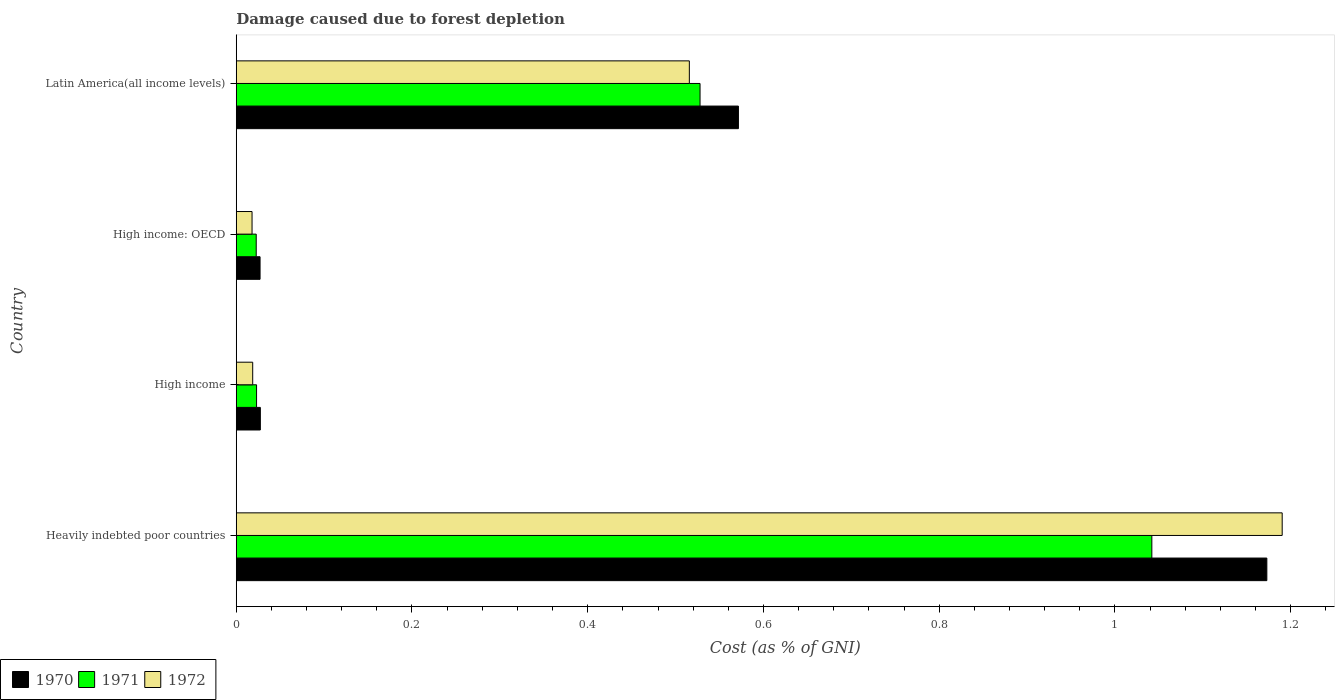How many different coloured bars are there?
Provide a succinct answer. 3. How many groups of bars are there?
Make the answer very short. 4. What is the label of the 1st group of bars from the top?
Provide a succinct answer. Latin America(all income levels). What is the cost of damage caused due to forest depletion in 1971 in High income?
Make the answer very short. 0.02. Across all countries, what is the maximum cost of damage caused due to forest depletion in 1970?
Give a very brief answer. 1.17. Across all countries, what is the minimum cost of damage caused due to forest depletion in 1971?
Offer a terse response. 0.02. In which country was the cost of damage caused due to forest depletion in 1972 maximum?
Give a very brief answer. Heavily indebted poor countries. In which country was the cost of damage caused due to forest depletion in 1970 minimum?
Offer a terse response. High income: OECD. What is the total cost of damage caused due to forest depletion in 1970 in the graph?
Offer a very short reply. 1.8. What is the difference between the cost of damage caused due to forest depletion in 1972 in Heavily indebted poor countries and that in High income?
Ensure brevity in your answer.  1.17. What is the difference between the cost of damage caused due to forest depletion in 1972 in Heavily indebted poor countries and the cost of damage caused due to forest depletion in 1971 in High income: OECD?
Your response must be concise. 1.17. What is the average cost of damage caused due to forest depletion in 1972 per country?
Your response must be concise. 0.44. What is the difference between the cost of damage caused due to forest depletion in 1970 and cost of damage caused due to forest depletion in 1971 in Latin America(all income levels)?
Your answer should be very brief. 0.04. What is the ratio of the cost of damage caused due to forest depletion in 1970 in Heavily indebted poor countries to that in Latin America(all income levels)?
Make the answer very short. 2.05. What is the difference between the highest and the second highest cost of damage caused due to forest depletion in 1972?
Your answer should be compact. 0.67. What is the difference between the highest and the lowest cost of damage caused due to forest depletion in 1971?
Give a very brief answer. 1.02. In how many countries, is the cost of damage caused due to forest depletion in 1970 greater than the average cost of damage caused due to forest depletion in 1970 taken over all countries?
Offer a very short reply. 2. Is it the case that in every country, the sum of the cost of damage caused due to forest depletion in 1971 and cost of damage caused due to forest depletion in 1970 is greater than the cost of damage caused due to forest depletion in 1972?
Your answer should be very brief. Yes. How many bars are there?
Provide a short and direct response. 12. Are all the bars in the graph horizontal?
Provide a short and direct response. Yes. How many countries are there in the graph?
Your answer should be very brief. 4. Does the graph contain any zero values?
Keep it short and to the point. No. Does the graph contain grids?
Your answer should be very brief. No. How many legend labels are there?
Give a very brief answer. 3. How are the legend labels stacked?
Keep it short and to the point. Horizontal. What is the title of the graph?
Keep it short and to the point. Damage caused due to forest depletion. What is the label or title of the X-axis?
Make the answer very short. Cost (as % of GNI). What is the Cost (as % of GNI) in 1970 in Heavily indebted poor countries?
Provide a succinct answer. 1.17. What is the Cost (as % of GNI) of 1971 in Heavily indebted poor countries?
Your answer should be very brief. 1.04. What is the Cost (as % of GNI) of 1972 in Heavily indebted poor countries?
Make the answer very short. 1.19. What is the Cost (as % of GNI) of 1970 in High income?
Offer a terse response. 0.03. What is the Cost (as % of GNI) of 1971 in High income?
Your response must be concise. 0.02. What is the Cost (as % of GNI) of 1972 in High income?
Provide a succinct answer. 0.02. What is the Cost (as % of GNI) of 1970 in High income: OECD?
Keep it short and to the point. 0.03. What is the Cost (as % of GNI) in 1971 in High income: OECD?
Provide a short and direct response. 0.02. What is the Cost (as % of GNI) of 1972 in High income: OECD?
Your response must be concise. 0.02. What is the Cost (as % of GNI) of 1970 in Latin America(all income levels)?
Ensure brevity in your answer.  0.57. What is the Cost (as % of GNI) in 1971 in Latin America(all income levels)?
Your response must be concise. 0.53. What is the Cost (as % of GNI) of 1972 in Latin America(all income levels)?
Your answer should be compact. 0.52. Across all countries, what is the maximum Cost (as % of GNI) of 1970?
Ensure brevity in your answer.  1.17. Across all countries, what is the maximum Cost (as % of GNI) in 1971?
Ensure brevity in your answer.  1.04. Across all countries, what is the maximum Cost (as % of GNI) of 1972?
Your answer should be compact. 1.19. Across all countries, what is the minimum Cost (as % of GNI) in 1970?
Your answer should be very brief. 0.03. Across all countries, what is the minimum Cost (as % of GNI) of 1971?
Make the answer very short. 0.02. Across all countries, what is the minimum Cost (as % of GNI) of 1972?
Ensure brevity in your answer.  0.02. What is the total Cost (as % of GNI) of 1970 in the graph?
Your answer should be compact. 1.8. What is the total Cost (as % of GNI) in 1971 in the graph?
Provide a short and direct response. 1.62. What is the total Cost (as % of GNI) of 1972 in the graph?
Your response must be concise. 1.74. What is the difference between the Cost (as % of GNI) of 1970 in Heavily indebted poor countries and that in High income?
Give a very brief answer. 1.15. What is the difference between the Cost (as % of GNI) of 1971 in Heavily indebted poor countries and that in High income?
Provide a succinct answer. 1.02. What is the difference between the Cost (as % of GNI) in 1972 in Heavily indebted poor countries and that in High income?
Your response must be concise. 1.17. What is the difference between the Cost (as % of GNI) of 1970 in Heavily indebted poor countries and that in High income: OECD?
Your answer should be very brief. 1.15. What is the difference between the Cost (as % of GNI) in 1971 in Heavily indebted poor countries and that in High income: OECD?
Offer a terse response. 1.02. What is the difference between the Cost (as % of GNI) of 1972 in Heavily indebted poor countries and that in High income: OECD?
Make the answer very short. 1.17. What is the difference between the Cost (as % of GNI) of 1970 in Heavily indebted poor countries and that in Latin America(all income levels)?
Your answer should be very brief. 0.6. What is the difference between the Cost (as % of GNI) of 1971 in Heavily indebted poor countries and that in Latin America(all income levels)?
Keep it short and to the point. 0.51. What is the difference between the Cost (as % of GNI) of 1972 in Heavily indebted poor countries and that in Latin America(all income levels)?
Make the answer very short. 0.67. What is the difference between the Cost (as % of GNI) in 1970 in High income and that in High income: OECD?
Offer a terse response. 0. What is the difference between the Cost (as % of GNI) in 1972 in High income and that in High income: OECD?
Offer a very short reply. 0. What is the difference between the Cost (as % of GNI) in 1970 in High income and that in Latin America(all income levels)?
Your answer should be compact. -0.54. What is the difference between the Cost (as % of GNI) of 1971 in High income and that in Latin America(all income levels)?
Ensure brevity in your answer.  -0.5. What is the difference between the Cost (as % of GNI) of 1972 in High income and that in Latin America(all income levels)?
Offer a terse response. -0.5. What is the difference between the Cost (as % of GNI) of 1970 in High income: OECD and that in Latin America(all income levels)?
Your answer should be very brief. -0.54. What is the difference between the Cost (as % of GNI) of 1971 in High income: OECD and that in Latin America(all income levels)?
Offer a very short reply. -0.51. What is the difference between the Cost (as % of GNI) of 1972 in High income: OECD and that in Latin America(all income levels)?
Provide a succinct answer. -0.5. What is the difference between the Cost (as % of GNI) of 1970 in Heavily indebted poor countries and the Cost (as % of GNI) of 1971 in High income?
Offer a terse response. 1.15. What is the difference between the Cost (as % of GNI) in 1970 in Heavily indebted poor countries and the Cost (as % of GNI) in 1972 in High income?
Offer a terse response. 1.15. What is the difference between the Cost (as % of GNI) of 1971 in Heavily indebted poor countries and the Cost (as % of GNI) of 1972 in High income?
Offer a terse response. 1.02. What is the difference between the Cost (as % of GNI) in 1970 in Heavily indebted poor countries and the Cost (as % of GNI) in 1971 in High income: OECD?
Your answer should be compact. 1.15. What is the difference between the Cost (as % of GNI) of 1970 in Heavily indebted poor countries and the Cost (as % of GNI) of 1972 in High income: OECD?
Keep it short and to the point. 1.15. What is the difference between the Cost (as % of GNI) in 1971 in Heavily indebted poor countries and the Cost (as % of GNI) in 1972 in High income: OECD?
Your answer should be very brief. 1.02. What is the difference between the Cost (as % of GNI) of 1970 in Heavily indebted poor countries and the Cost (as % of GNI) of 1971 in Latin America(all income levels)?
Offer a terse response. 0.65. What is the difference between the Cost (as % of GNI) of 1970 in Heavily indebted poor countries and the Cost (as % of GNI) of 1972 in Latin America(all income levels)?
Offer a very short reply. 0.66. What is the difference between the Cost (as % of GNI) in 1971 in Heavily indebted poor countries and the Cost (as % of GNI) in 1972 in Latin America(all income levels)?
Offer a very short reply. 0.53. What is the difference between the Cost (as % of GNI) of 1970 in High income and the Cost (as % of GNI) of 1971 in High income: OECD?
Your answer should be very brief. 0. What is the difference between the Cost (as % of GNI) in 1970 in High income and the Cost (as % of GNI) in 1972 in High income: OECD?
Give a very brief answer. 0.01. What is the difference between the Cost (as % of GNI) in 1971 in High income and the Cost (as % of GNI) in 1972 in High income: OECD?
Make the answer very short. 0.01. What is the difference between the Cost (as % of GNI) in 1970 in High income and the Cost (as % of GNI) in 1971 in Latin America(all income levels)?
Your response must be concise. -0.5. What is the difference between the Cost (as % of GNI) in 1970 in High income and the Cost (as % of GNI) in 1972 in Latin America(all income levels)?
Your response must be concise. -0.49. What is the difference between the Cost (as % of GNI) of 1971 in High income and the Cost (as % of GNI) of 1972 in Latin America(all income levels)?
Your answer should be very brief. -0.49. What is the difference between the Cost (as % of GNI) in 1970 in High income: OECD and the Cost (as % of GNI) in 1971 in Latin America(all income levels)?
Your answer should be compact. -0.5. What is the difference between the Cost (as % of GNI) of 1970 in High income: OECD and the Cost (as % of GNI) of 1972 in Latin America(all income levels)?
Your response must be concise. -0.49. What is the difference between the Cost (as % of GNI) in 1971 in High income: OECD and the Cost (as % of GNI) in 1972 in Latin America(all income levels)?
Provide a succinct answer. -0.49. What is the average Cost (as % of GNI) in 1970 per country?
Give a very brief answer. 0.45. What is the average Cost (as % of GNI) of 1971 per country?
Your answer should be very brief. 0.4. What is the average Cost (as % of GNI) in 1972 per country?
Offer a very short reply. 0.44. What is the difference between the Cost (as % of GNI) in 1970 and Cost (as % of GNI) in 1971 in Heavily indebted poor countries?
Your response must be concise. 0.13. What is the difference between the Cost (as % of GNI) in 1970 and Cost (as % of GNI) in 1972 in Heavily indebted poor countries?
Keep it short and to the point. -0.02. What is the difference between the Cost (as % of GNI) in 1971 and Cost (as % of GNI) in 1972 in Heavily indebted poor countries?
Keep it short and to the point. -0.15. What is the difference between the Cost (as % of GNI) of 1970 and Cost (as % of GNI) of 1971 in High income?
Provide a short and direct response. 0. What is the difference between the Cost (as % of GNI) of 1970 and Cost (as % of GNI) of 1972 in High income?
Provide a short and direct response. 0.01. What is the difference between the Cost (as % of GNI) in 1971 and Cost (as % of GNI) in 1972 in High income?
Offer a very short reply. 0. What is the difference between the Cost (as % of GNI) in 1970 and Cost (as % of GNI) in 1971 in High income: OECD?
Offer a terse response. 0. What is the difference between the Cost (as % of GNI) in 1970 and Cost (as % of GNI) in 1972 in High income: OECD?
Your answer should be compact. 0.01. What is the difference between the Cost (as % of GNI) in 1971 and Cost (as % of GNI) in 1972 in High income: OECD?
Give a very brief answer. 0. What is the difference between the Cost (as % of GNI) in 1970 and Cost (as % of GNI) in 1971 in Latin America(all income levels)?
Keep it short and to the point. 0.04. What is the difference between the Cost (as % of GNI) in 1970 and Cost (as % of GNI) in 1972 in Latin America(all income levels)?
Make the answer very short. 0.06. What is the difference between the Cost (as % of GNI) in 1971 and Cost (as % of GNI) in 1972 in Latin America(all income levels)?
Your response must be concise. 0.01. What is the ratio of the Cost (as % of GNI) of 1970 in Heavily indebted poor countries to that in High income?
Your answer should be compact. 42.78. What is the ratio of the Cost (as % of GNI) in 1971 in Heavily indebted poor countries to that in High income?
Ensure brevity in your answer.  45.1. What is the ratio of the Cost (as % of GNI) in 1972 in Heavily indebted poor countries to that in High income?
Ensure brevity in your answer.  63.61. What is the ratio of the Cost (as % of GNI) of 1970 in Heavily indebted poor countries to that in High income: OECD?
Keep it short and to the point. 43.29. What is the ratio of the Cost (as % of GNI) in 1971 in Heavily indebted poor countries to that in High income: OECD?
Give a very brief answer. 45.86. What is the ratio of the Cost (as % of GNI) of 1972 in Heavily indebted poor countries to that in High income: OECD?
Offer a very short reply. 66.22. What is the ratio of the Cost (as % of GNI) in 1970 in Heavily indebted poor countries to that in Latin America(all income levels)?
Make the answer very short. 2.05. What is the ratio of the Cost (as % of GNI) in 1971 in Heavily indebted poor countries to that in Latin America(all income levels)?
Offer a terse response. 1.97. What is the ratio of the Cost (as % of GNI) of 1972 in Heavily indebted poor countries to that in Latin America(all income levels)?
Offer a very short reply. 2.31. What is the ratio of the Cost (as % of GNI) of 1970 in High income to that in High income: OECD?
Offer a very short reply. 1.01. What is the ratio of the Cost (as % of GNI) in 1971 in High income to that in High income: OECD?
Keep it short and to the point. 1.02. What is the ratio of the Cost (as % of GNI) in 1972 in High income to that in High income: OECD?
Your answer should be very brief. 1.04. What is the ratio of the Cost (as % of GNI) of 1970 in High income to that in Latin America(all income levels)?
Your response must be concise. 0.05. What is the ratio of the Cost (as % of GNI) of 1971 in High income to that in Latin America(all income levels)?
Your response must be concise. 0.04. What is the ratio of the Cost (as % of GNI) in 1972 in High income to that in Latin America(all income levels)?
Offer a terse response. 0.04. What is the ratio of the Cost (as % of GNI) in 1970 in High income: OECD to that in Latin America(all income levels)?
Ensure brevity in your answer.  0.05. What is the ratio of the Cost (as % of GNI) of 1971 in High income: OECD to that in Latin America(all income levels)?
Give a very brief answer. 0.04. What is the ratio of the Cost (as % of GNI) of 1972 in High income: OECD to that in Latin America(all income levels)?
Keep it short and to the point. 0.03. What is the difference between the highest and the second highest Cost (as % of GNI) of 1970?
Your answer should be very brief. 0.6. What is the difference between the highest and the second highest Cost (as % of GNI) in 1971?
Ensure brevity in your answer.  0.51. What is the difference between the highest and the second highest Cost (as % of GNI) in 1972?
Give a very brief answer. 0.67. What is the difference between the highest and the lowest Cost (as % of GNI) in 1970?
Provide a short and direct response. 1.15. What is the difference between the highest and the lowest Cost (as % of GNI) in 1971?
Make the answer very short. 1.02. What is the difference between the highest and the lowest Cost (as % of GNI) in 1972?
Provide a succinct answer. 1.17. 